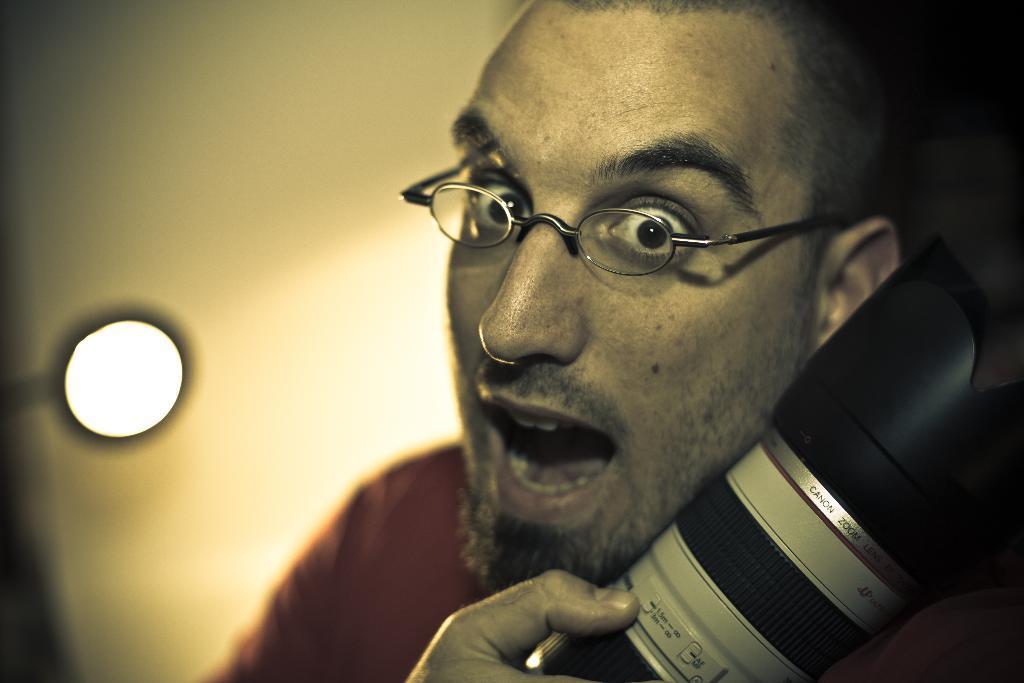Please provide a concise description of this image. In the center of the image, we can see a person wearing glasses and holding a camera. In the background, there is a light and a wall. 